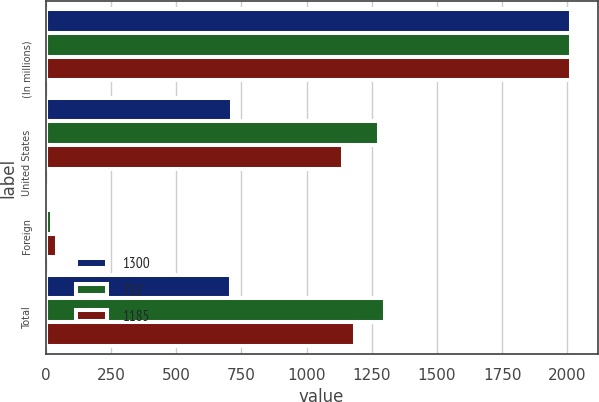Convert chart. <chart><loc_0><loc_0><loc_500><loc_500><stacked_bar_chart><ecel><fcel>(In millions)<fcel>United States<fcel>Foreign<fcel>Total<nl><fcel>1300<fcel>2015<fcel>716<fcel>4<fcel>712<nl><fcel>712<fcel>2014<fcel>1276<fcel>24<fcel>1300<nl><fcel>1185<fcel>2013<fcel>1140<fcel>45<fcel>1185<nl></chart> 